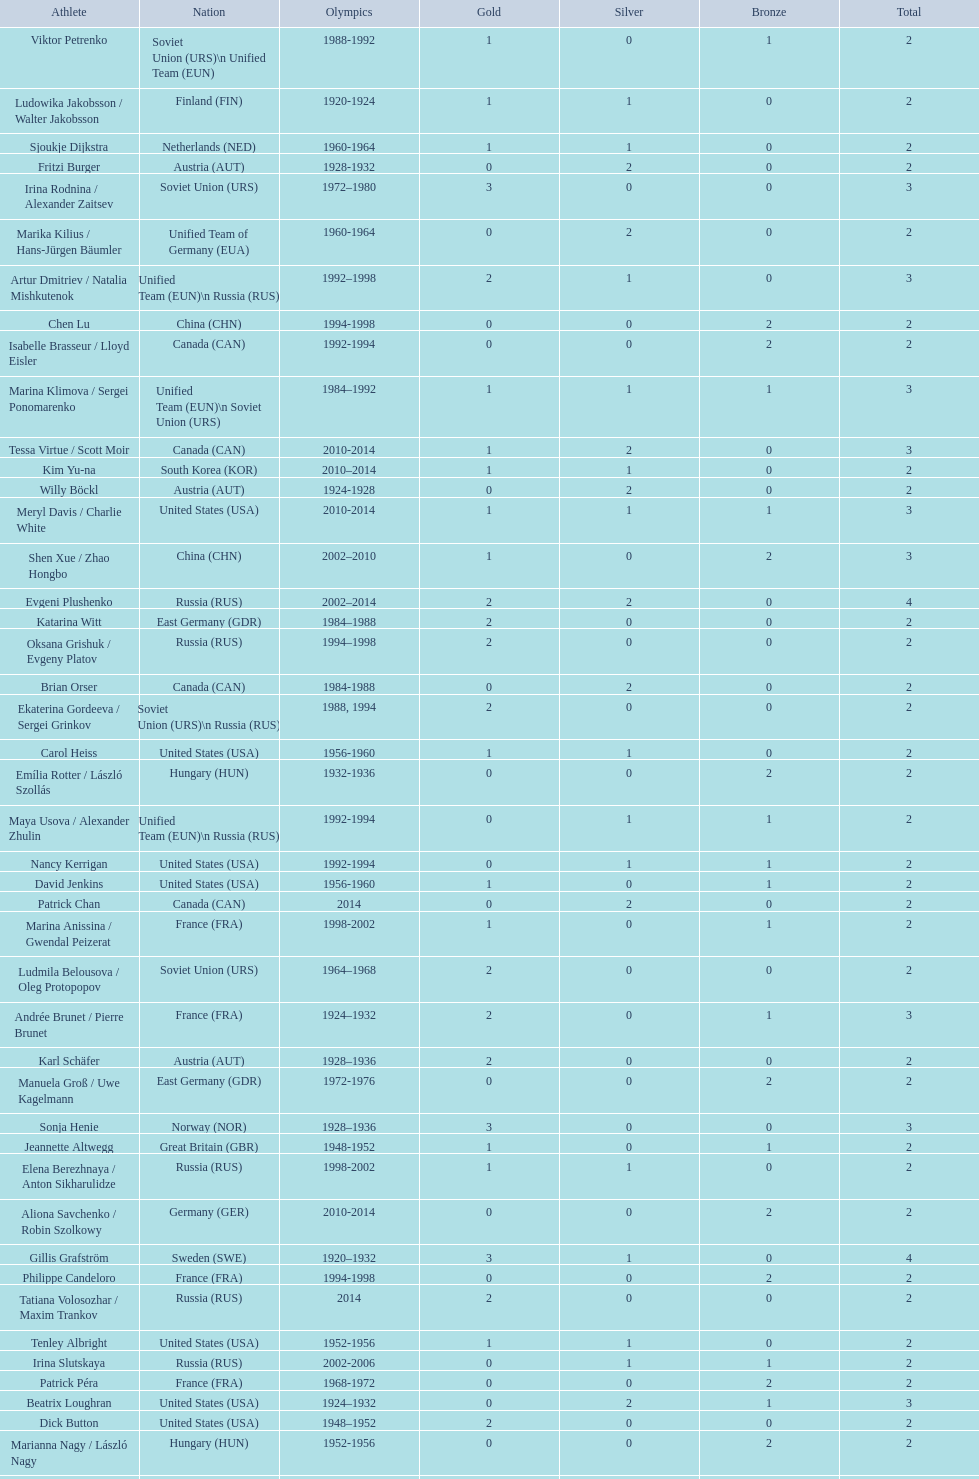How many silver medals did evgeni plushenko get? 2. 